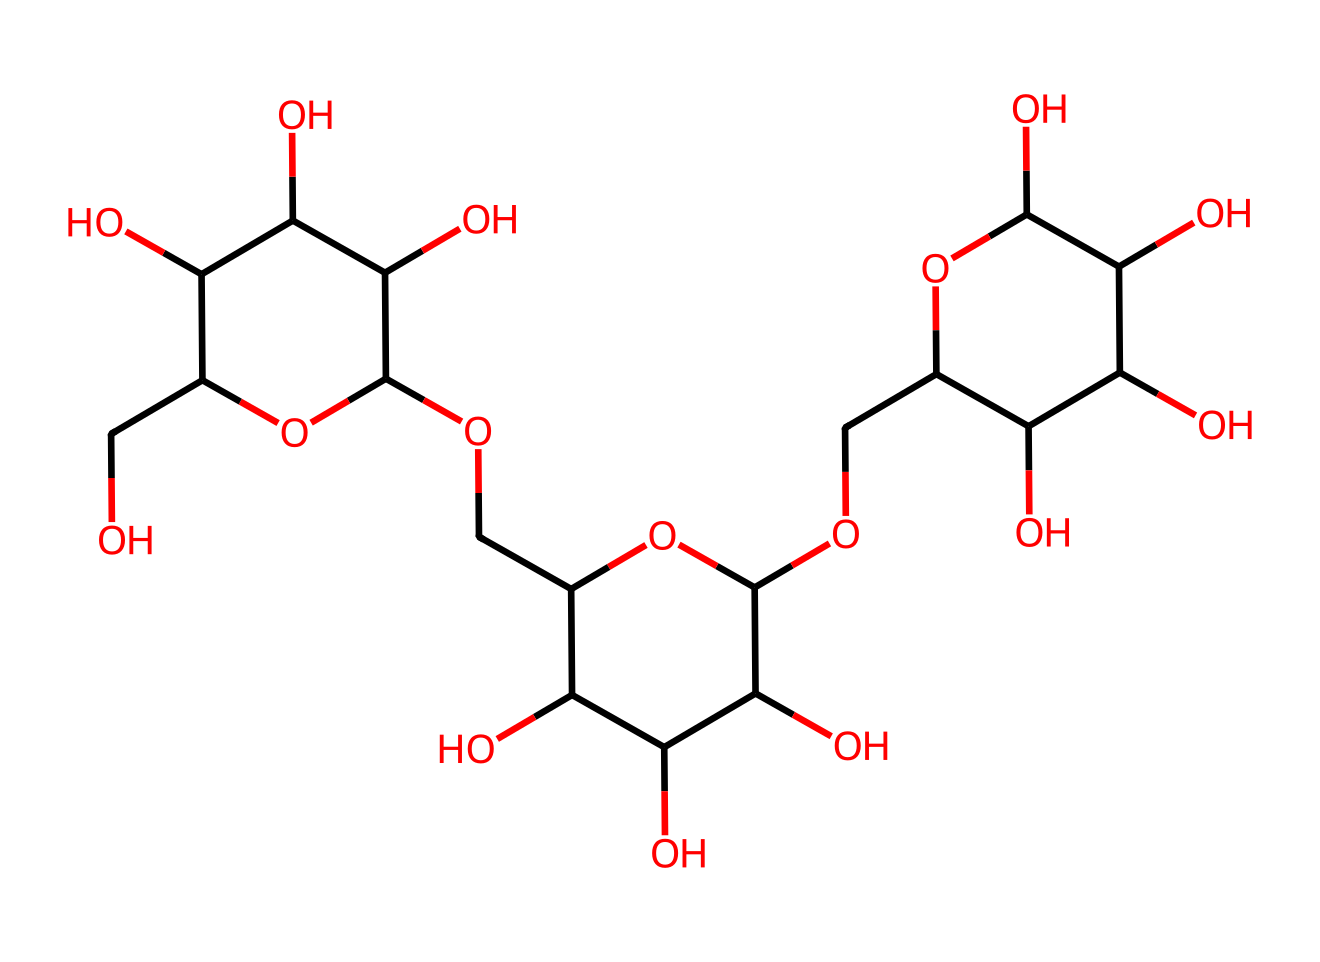What is the name of this chemical? The provided SMILES representation corresponds to a carbohydrate, specifically a polysaccharide known as maltodextrin. This can be identified by recognizing its structure as a chain of glucose units.
Answer: maltodextrin How many carbon atoms are present in the structure? By examining the SMILES notation, we count the number of 'C' characters which represent carbon atoms. The total carbon count from the chemical structure reveals there are 30 carbon atoms.
Answer: 30 What type of carbohydrate is maltodextrin? Maltodextrin is classified as a polysaccharide, which can be deduced from its lengthy structure composed of multiple monosaccharide units connected by glycosidic bonds.
Answer: polysaccharide What functional groups are prominently featured in maltodextrin? The molecule has hydroxyl (-OH) groups, which are evident in the structure. By identifying the -O atoms connected to hydrogen atoms, we can confirm these are hydroxyl groups.
Answer: hydroxyl groups What is the primary characteristic of maltodextrin in terms of sweetness? Maltodextrin is known for having low sweetness, which can be inferred from its structural composition—polysaccharides typically do not taste sweet compared to simpler sugars.
Answer: low sweetness How does the structure of maltodextrin affect its solubility in water? The numerous hydroxyl groups in the structure increase maltodextrin's solubility in water, as these groups can form hydrogen bonds with water molecules, enhancing its ability to dissolve.
Answer: high solubility 